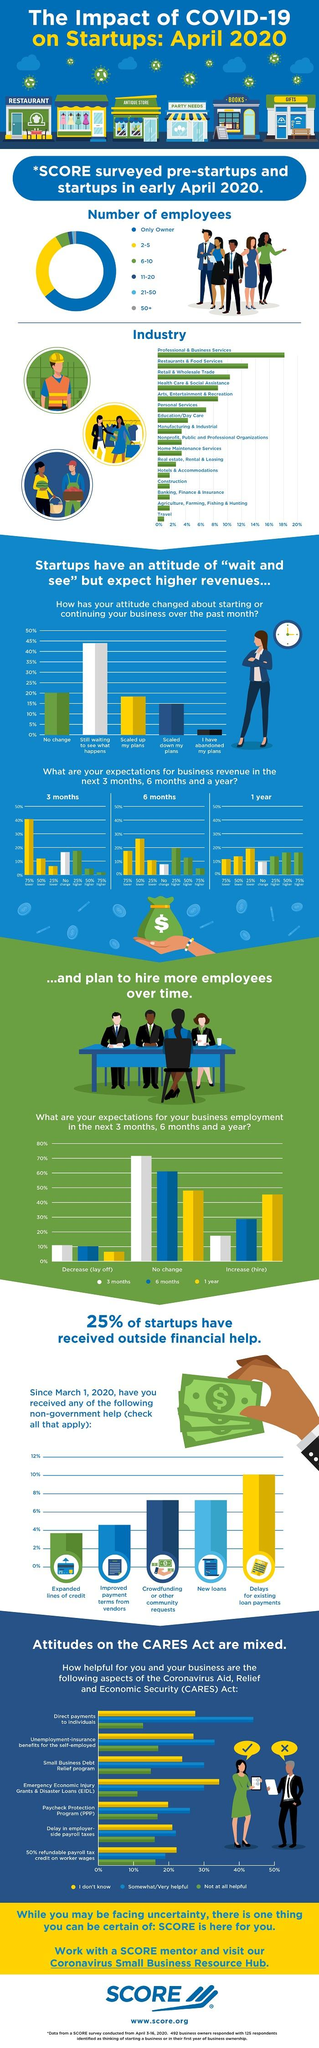Point out several critical features in this image. In the pie chart, approximately 6 to 10 employees are represented by the color green. The Professional & Business Services industry has reached 18% as per the graph. According to the bar graph, 20% of startups have an attitude that there will be no change in their marketing strategy. A significant percentage of people believe that there will be a layoff in the next six months, with 10% of respondents expressing this sentiment. In six months, 60% of people expect no change in employment. 